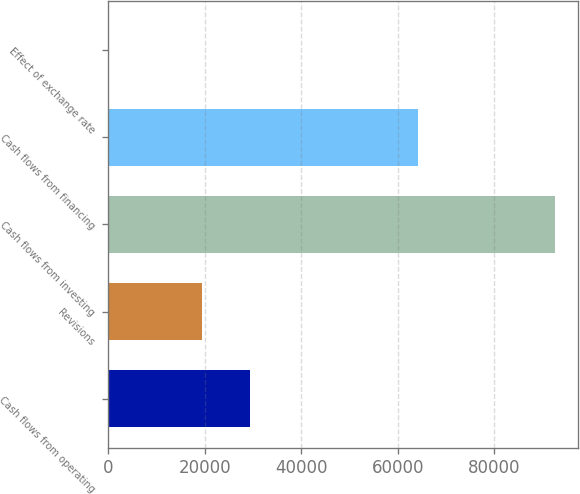Convert chart to OTSL. <chart><loc_0><loc_0><loc_500><loc_500><bar_chart><fcel>Cash flows from operating<fcel>Revisions<fcel>Cash flows from investing<fcel>Cash flows from financing<fcel>Effect of exchange rate<nl><fcel>29414<fcel>19464.6<fcel>92596<fcel>64217<fcel>52<nl></chart> 